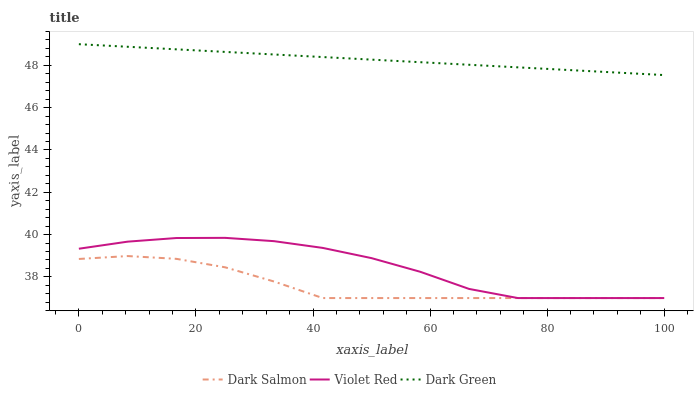Does Dark Salmon have the minimum area under the curve?
Answer yes or no. Yes. Does Dark Green have the maximum area under the curve?
Answer yes or no. Yes. Does Dark Green have the minimum area under the curve?
Answer yes or no. No. Does Dark Salmon have the maximum area under the curve?
Answer yes or no. No. Is Dark Green the smoothest?
Answer yes or no. Yes. Is Violet Red the roughest?
Answer yes or no. Yes. Is Dark Salmon the smoothest?
Answer yes or no. No. Is Dark Salmon the roughest?
Answer yes or no. No. Does Violet Red have the lowest value?
Answer yes or no. Yes. Does Dark Green have the lowest value?
Answer yes or no. No. Does Dark Green have the highest value?
Answer yes or no. Yes. Does Dark Salmon have the highest value?
Answer yes or no. No. Is Dark Salmon less than Dark Green?
Answer yes or no. Yes. Is Dark Green greater than Violet Red?
Answer yes or no. Yes. Does Dark Salmon intersect Violet Red?
Answer yes or no. Yes. Is Dark Salmon less than Violet Red?
Answer yes or no. No. Is Dark Salmon greater than Violet Red?
Answer yes or no. No. Does Dark Salmon intersect Dark Green?
Answer yes or no. No. 